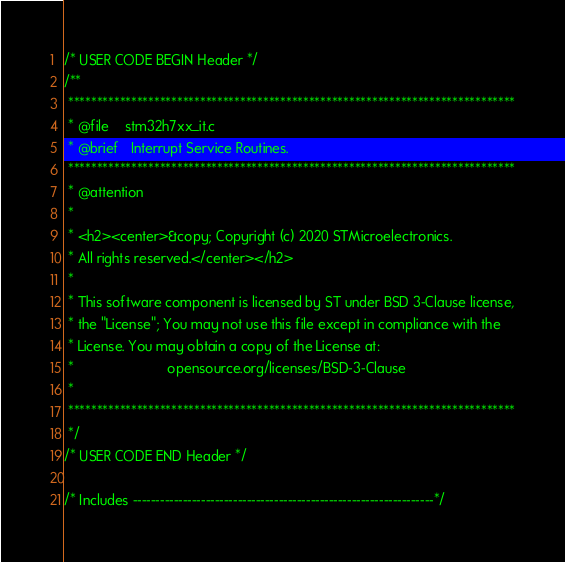<code> <loc_0><loc_0><loc_500><loc_500><_C++_>/* USER CODE BEGIN Header */
/**
 ******************************************************************************
 * @file    stm32h7xx_it.c
 * @brief   Interrupt Service Routines.
 ******************************************************************************
 * @attention
 *
 * <h2><center>&copy; Copyright (c) 2020 STMicroelectronics.
 * All rights reserved.</center></h2>
 *
 * This software component is licensed by ST under BSD 3-Clause license,
 * the "License"; You may not use this file except in compliance with the
 * License. You may obtain a copy of the License at:
 *                        opensource.org/licenses/BSD-3-Clause
 *
 ******************************************************************************
 */
/* USER CODE END Header */

/* Includes ------------------------------------------------------------------*/
</code> 